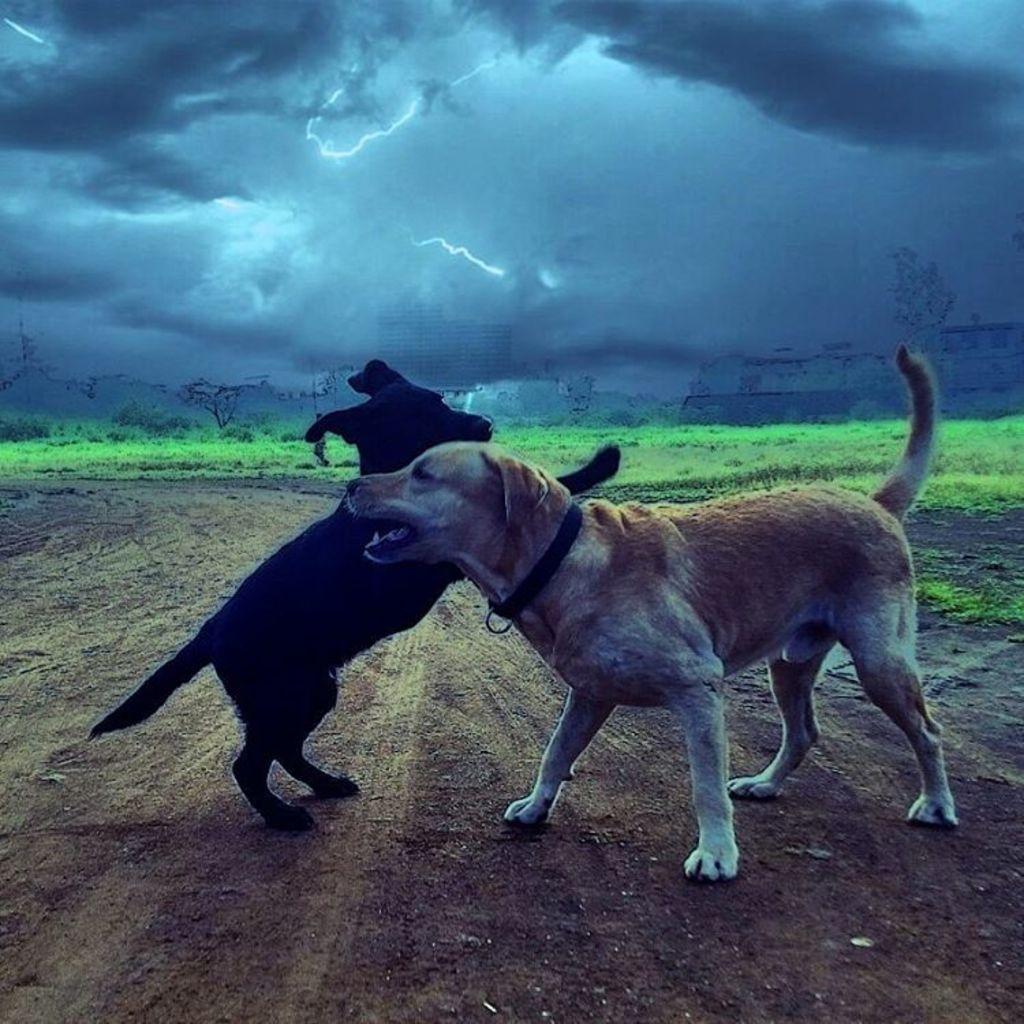Can you describe this image briefly? In this image we can see two dogs barking, in the background of the image there is grass and buildings. 